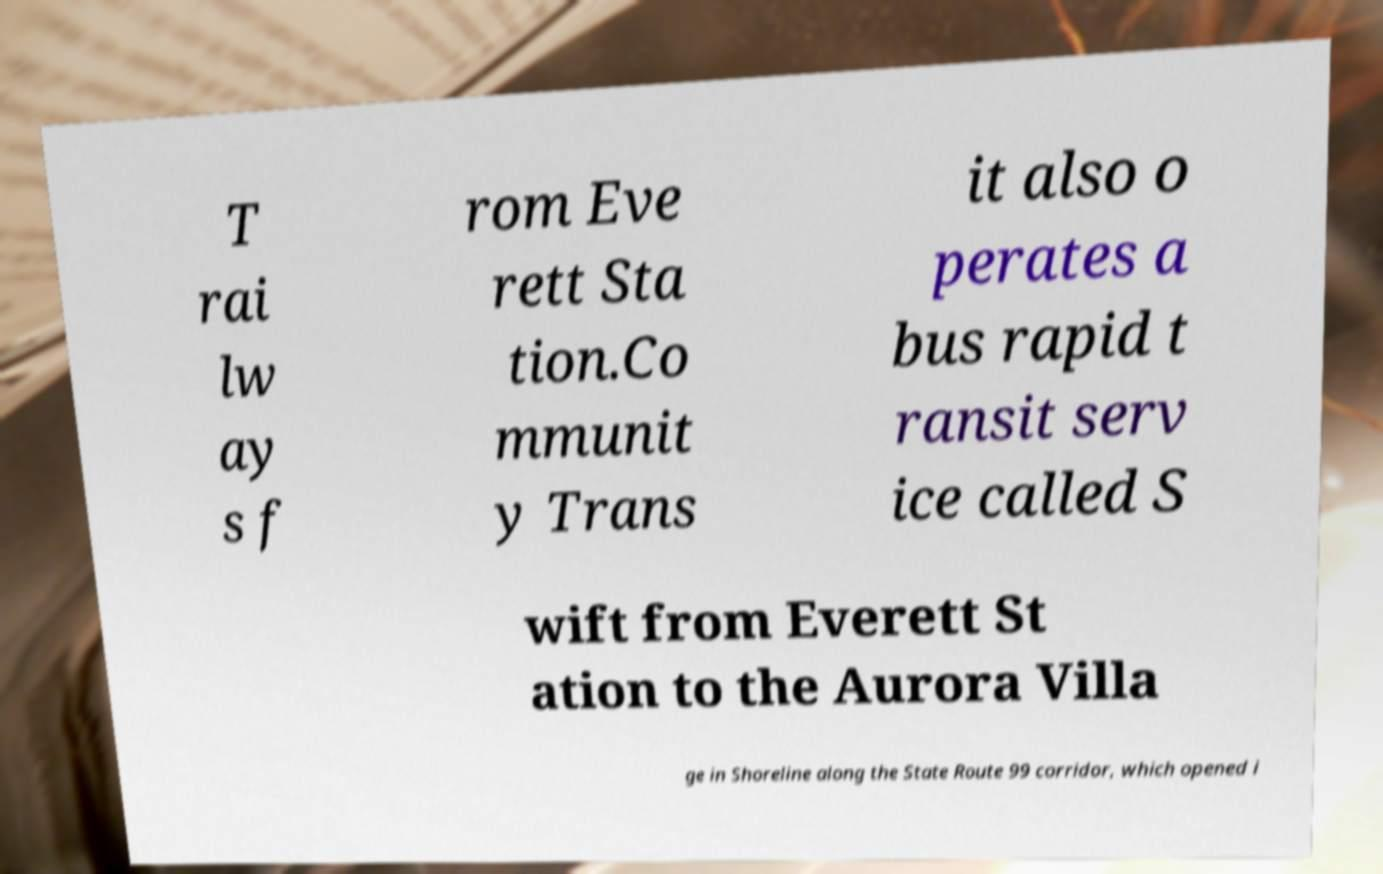Please read and relay the text visible in this image. What does it say? T rai lw ay s f rom Eve rett Sta tion.Co mmunit y Trans it also o perates a bus rapid t ransit serv ice called S wift from Everett St ation to the Aurora Villa ge in Shoreline along the State Route 99 corridor, which opened i 